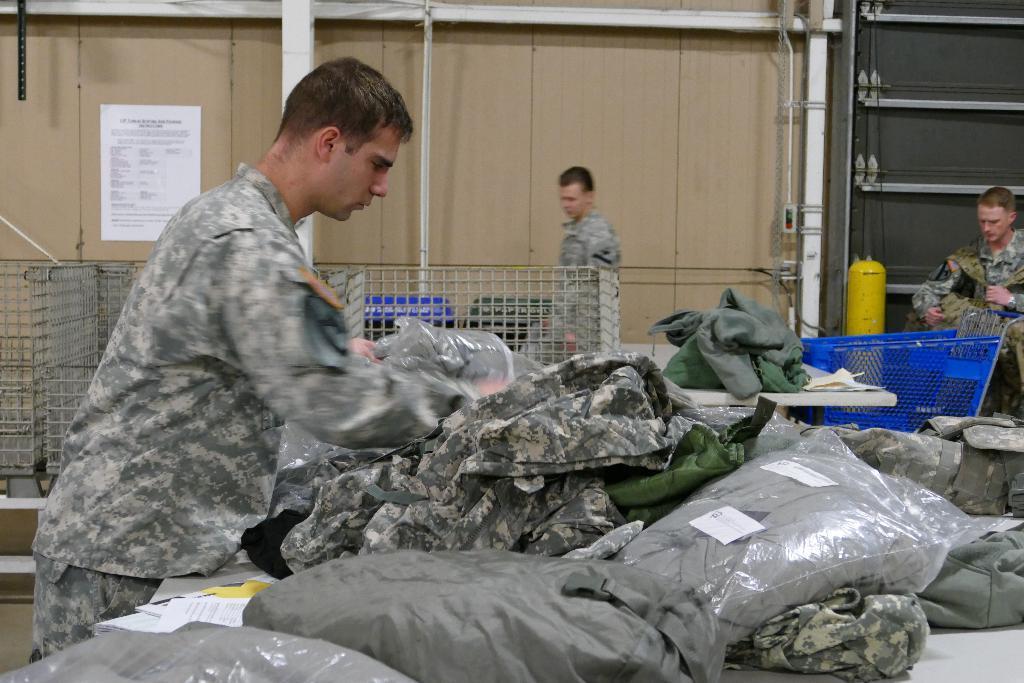In one or two sentences, can you explain what this image depicts? In this picture we can see people, here we can see clothes, wooden wall, poster and some objects. 